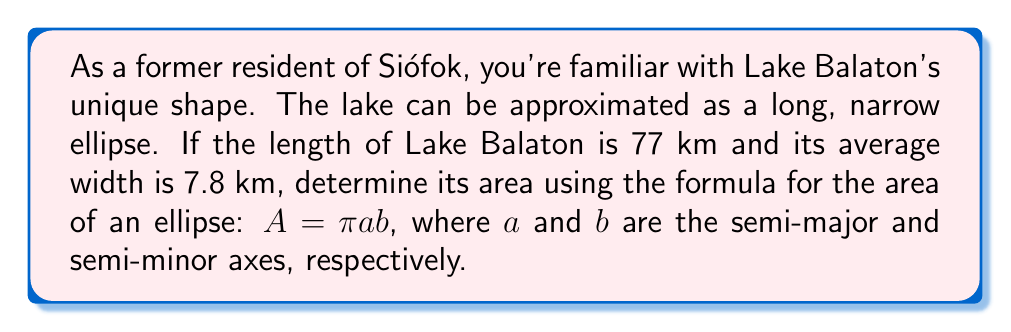Solve this math problem. To solve this problem, we need to follow these steps:

1. Identify the major and minor axes:
   - Major axis (length) = 77 km
   - Minor axis (width) = 7.8 km

2. Calculate the semi-major and semi-minor axes:
   - Semi-major axis (a) = $\frac{77}{2} = 38.5$ km
   - Semi-minor axis (b) = $\frac{7.8}{2} = 3.9$ km

3. Apply the formula for the area of an ellipse:
   $A = \pi ab$

4. Substitute the values:
   $A = \pi \cdot 38.5 \cdot 3.9$

5. Calculate:
   $A = \pi \cdot 150.15$
   $A \approx 471.48$ sq km

[asy]
size(200);
real a = 77;
real b = 7.8;
fill(scale(a/2,b/2)*unitcircle, rgb(0.7,0.9,1));
draw(scale(a/2,b/2)*unitcircle);
label("77 km", (a/2,0), E);
label("7.8 km", (0,b/2), N);
[/asy]
Answer: The approximate area of Lake Balaton is 471.48 square kilometers. 